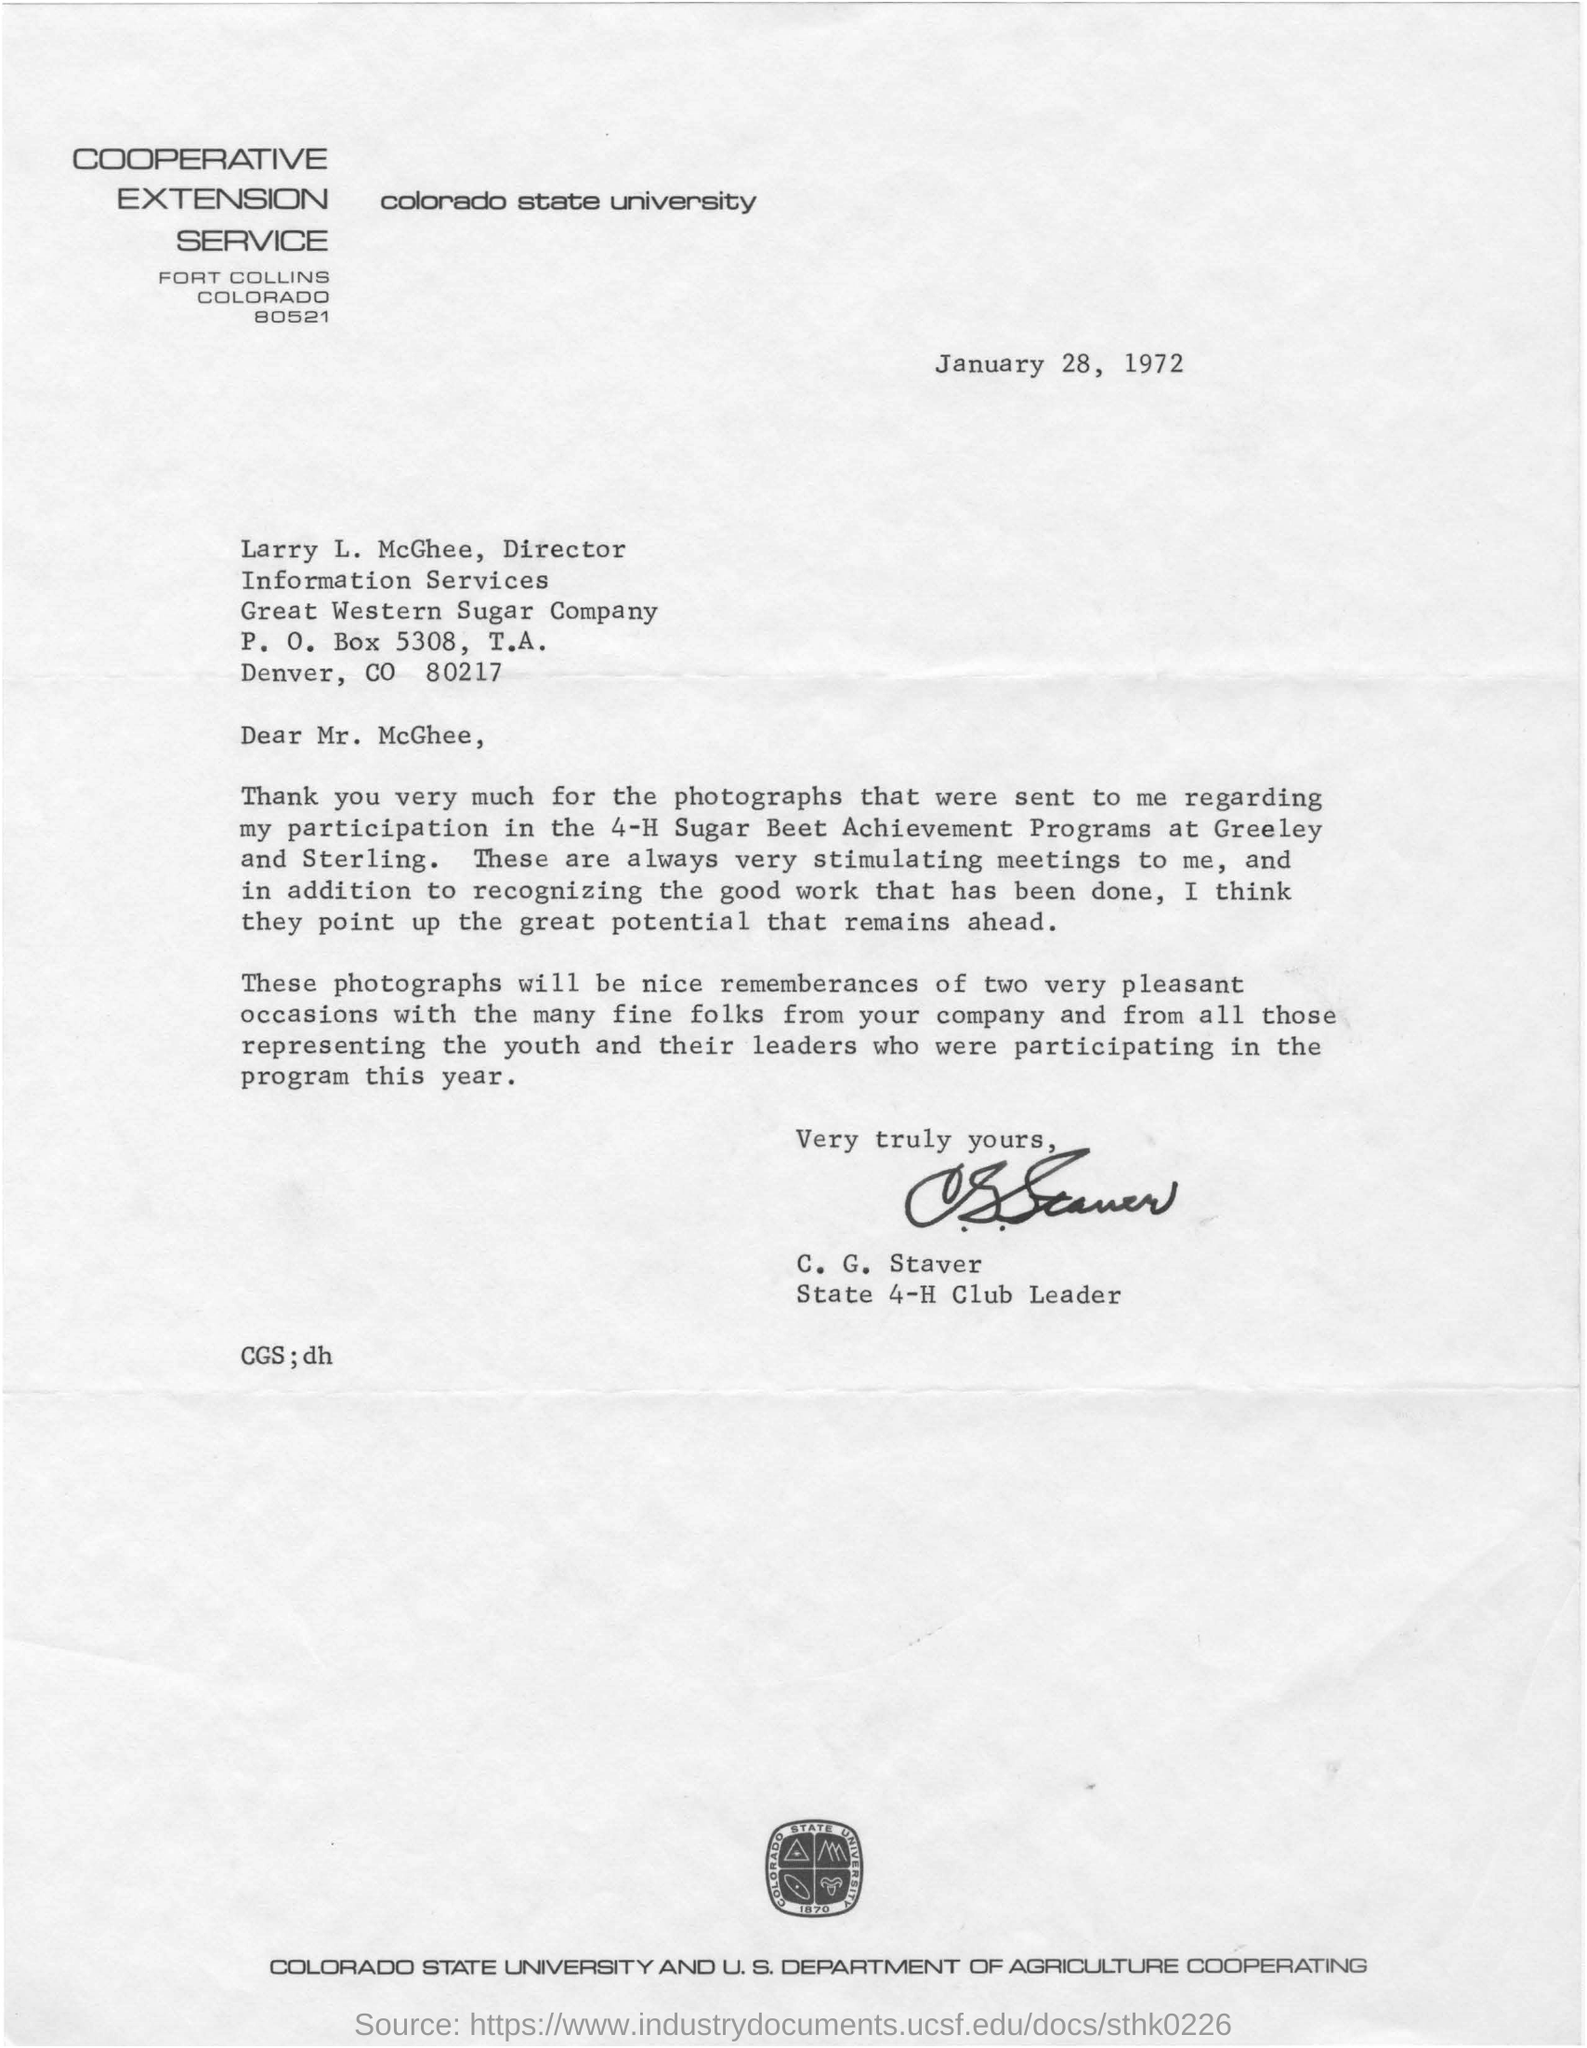Draw attention to some important aspects in this diagram. The date mentioned in the letter is January 28, 1972. The zip code of the recipient of the letter is 80217. The 4-H Sugar Beet Achievement Programs were conducted in Greeley and Sterling. The letter head mentions Colorado State University. 